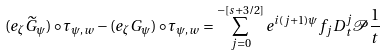<formula> <loc_0><loc_0><loc_500><loc_500>( e _ { \zeta } \widetilde { G } _ { \psi } ) \circ \tau _ { \psi , w } - ( e _ { \zeta } G _ { \psi } ) \circ \tau _ { \psi , w } = \sum _ { j = 0 } ^ { - [ s + 3 / 2 ] } e ^ { i ( j + 1 ) \psi } f _ { j } D _ { t } ^ { j } \mathcal { P } \frac { 1 } { t }</formula> 